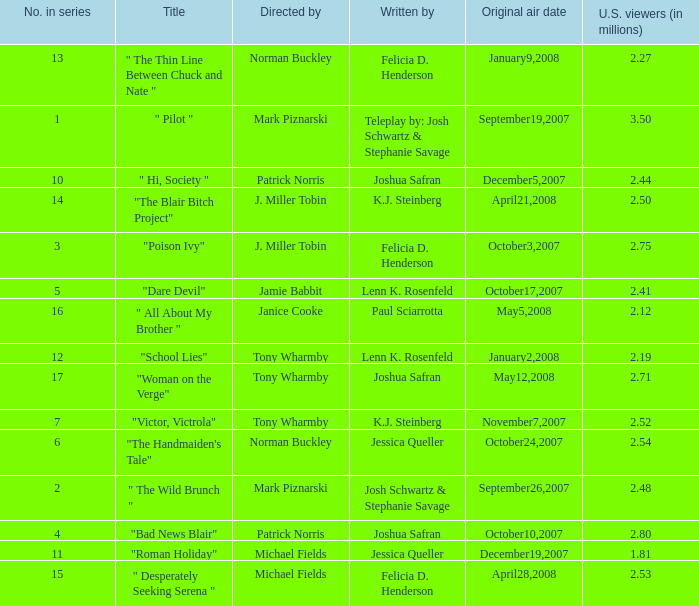How many u.s. viewers  (in millions) have "dare devil" as the title? 2.41. 